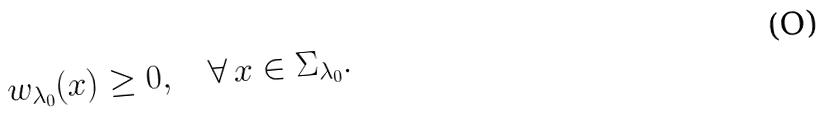<formula> <loc_0><loc_0><loc_500><loc_500>w _ { \lambda _ { 0 } } ( x ) \geq 0 , \quad \forall \, x \in \Sigma _ { \lambda _ { 0 } } .</formula> 